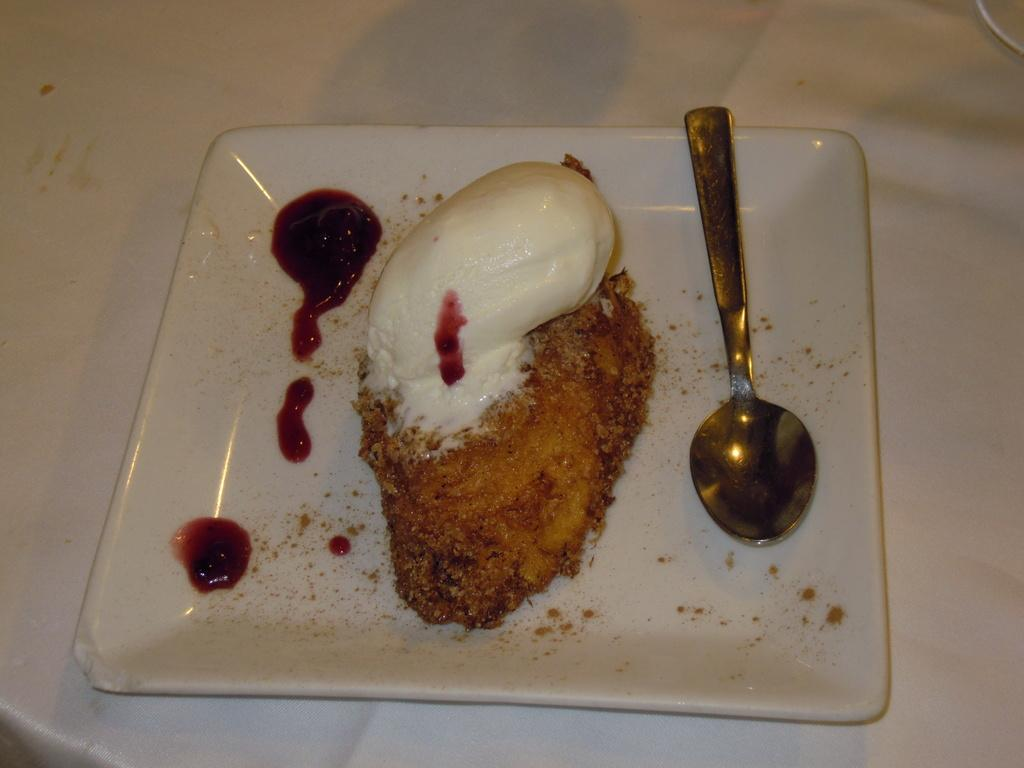What is on the plate in the foreground of the image? The plate contains a dessert. What utensil is present on the plate? There is a spoon on the plate. Can you describe the setting of the image? The image may have been taken in a room. How many boys are expressing anger in the image? There are no boys or expressions of anger present in the image. What type of spiders can be seen crawling on the dessert in the image? There are no spiders present in the image; it features a plate with dessert and a spoon. 